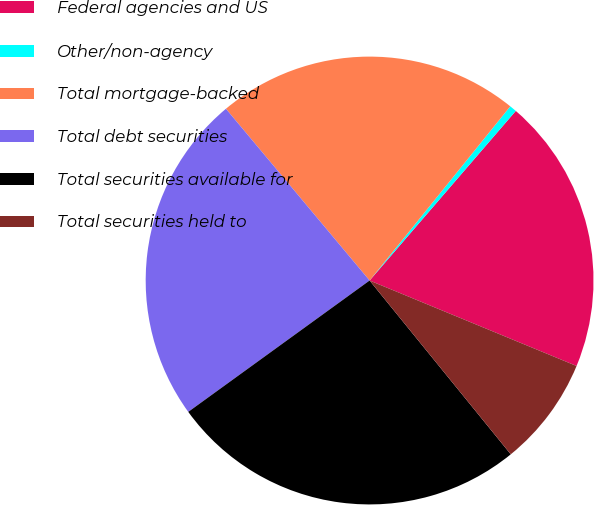Convert chart to OTSL. <chart><loc_0><loc_0><loc_500><loc_500><pie_chart><fcel>Federal agencies and US<fcel>Other/non-agency<fcel>Total mortgage-backed<fcel>Total debt securities<fcel>Total securities available for<fcel>Total securities held to<nl><fcel>19.91%<fcel>0.51%<fcel>21.9%<fcel>23.89%<fcel>25.88%<fcel>7.91%<nl></chart> 